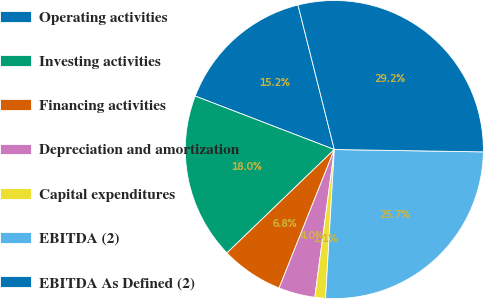Convert chart. <chart><loc_0><loc_0><loc_500><loc_500><pie_chart><fcel>Operating activities<fcel>Investing activities<fcel>Financing activities<fcel>Depreciation and amortization<fcel>Capital expenditures<fcel>EBITDA (2)<fcel>EBITDA As Defined (2)<nl><fcel>15.24%<fcel>18.04%<fcel>6.76%<fcel>3.95%<fcel>1.15%<fcel>25.69%<fcel>29.17%<nl></chart> 